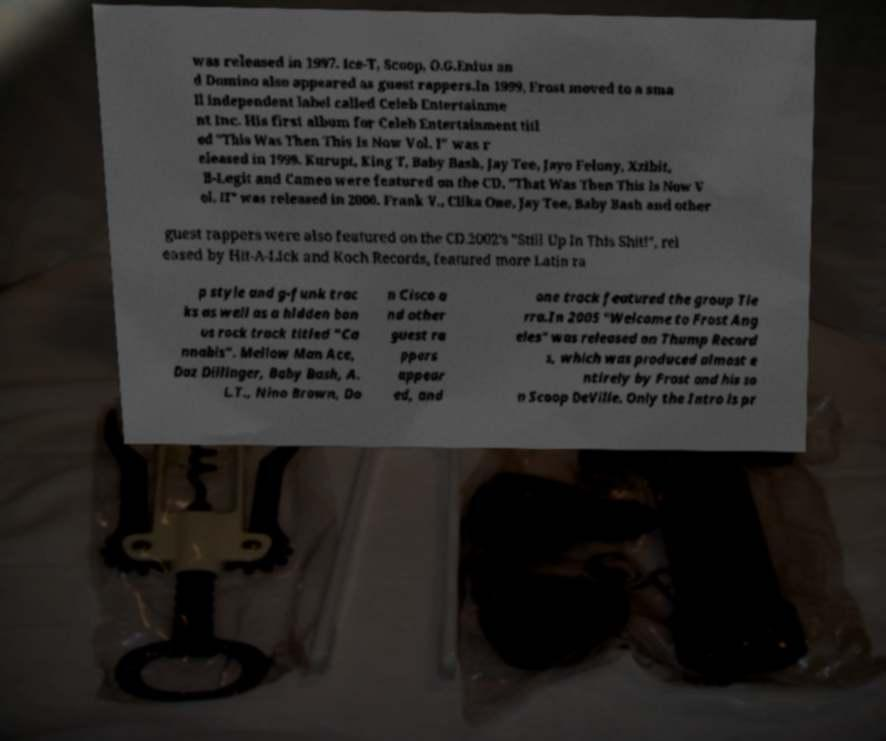Can you read and provide the text displayed in the image?This photo seems to have some interesting text. Can you extract and type it out for me? was released in 1997. Ice-T, Scoop, O.G.Enius an d Domino also appeared as guest rappers.In 1999, Frost moved to a sma ll independent label called Celeb Entertainme nt Inc. His first album for Celeb Entertainment titl ed "This Was Then This Is Now Vol. I" was r eleased in 1999. Kurupt, King T, Baby Bash, Jay Tee, Jayo Felony, Xzibit, B-Legit and Cameo were featured on the CD. "That Was Then This Is Now V ol. II" was released in 2000. Frank V., Clika One, Jay Tee, Baby Bash and other guest rappers were also featured on the CD.2002's "Still Up In This Shit!", rel eased by Hit-A-Lick and Koch Records, featured more Latin ra p style and g-funk trac ks as well as a hidden bon us rock track titled "Ca nnabis". Mellow Man Ace, Daz Dillinger, Baby Bash, A. L.T., Nino Brown, Do n Cisco a nd other guest ra ppers appear ed, and one track featured the group Tie rra.In 2005 "Welcome to Frost Ang eles" was released on Thump Record s, which was produced almost e ntirely by Frost and his so n Scoop DeVille. Only the Intro is pr 